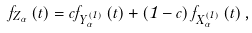<formula> <loc_0><loc_0><loc_500><loc_500>f _ { Z _ { \alpha } } \left ( t \right ) = c f _ { Y _ { \alpha } ^ { \left ( 1 \right ) } } \left ( t \right ) + \left ( 1 - c \right ) f _ { X _ { \alpha } ^ { \left ( 1 \right ) } } \left ( t \right ) ,</formula> 